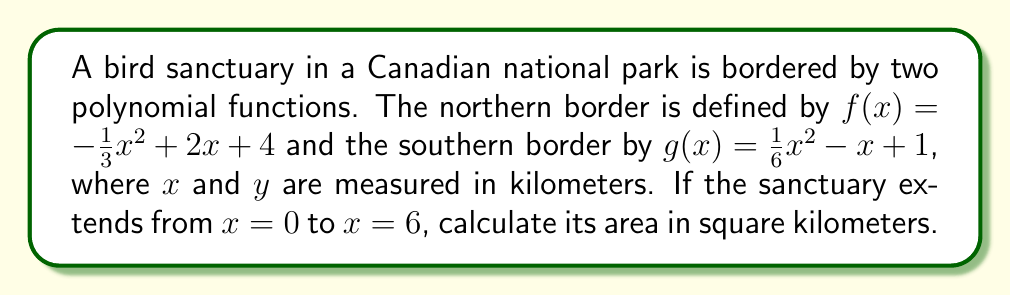Provide a solution to this math problem. To find the area of the bird sanctuary, we need to calculate the definite integral of the difference between the two functions from $x = 0$ to $x = 6$. Here's how we do it step by step:

1) The area is given by the integral:
   $$A = \int_0^6 [f(x) - g(x)] dx$$

2) Substitute the functions:
   $$A = \int_0^6 [(-\frac{1}{3}x^2 + 2x + 4) - (\frac{1}{6}x^2 - x + 1)] dx$$

3) Simplify the integrand:
   $$A = \int_0^6 [-\frac{1}{3}x^2 + 2x + 4 - \frac{1}{6}x^2 + x - 1] dx$$
   $$A = \int_0^6 [-\frac{1}{2}x^2 + 3x + 3] dx$$

4) Integrate:
   $$A = [-\frac{1}{6}x^3 + \frac{3}{2}x^2 + 3x]_0^6$$

5) Evaluate the integral:
   $$A = [-\frac{1}{6}(6^3) + \frac{3}{2}(6^2) + 3(6)] - [-\frac{1}{6}(0^3) + \frac{3}{2}(0^2) + 3(0)]$$
   $$A = [-36 + 54 + 18] - [0]$$
   $$A = 36$$

Therefore, the area of the bird sanctuary is 36 square kilometers.
Answer: 36 km² 